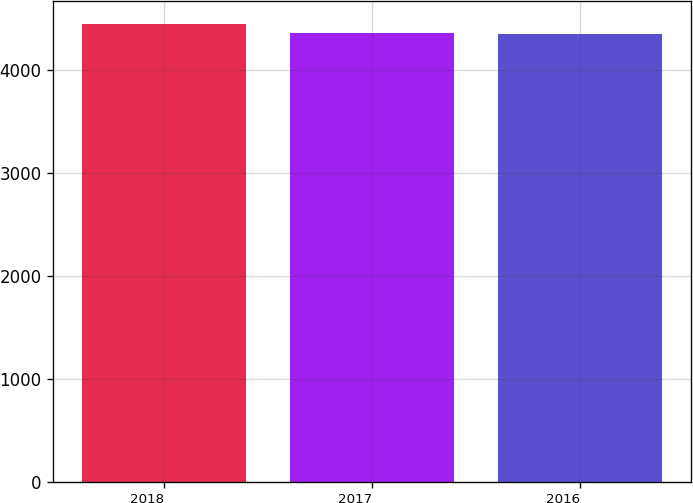Convert chart. <chart><loc_0><loc_0><loc_500><loc_500><bar_chart><fcel>2018<fcel>2017<fcel>2016<nl><fcel>4447<fcel>4357<fcel>4347<nl></chart> 